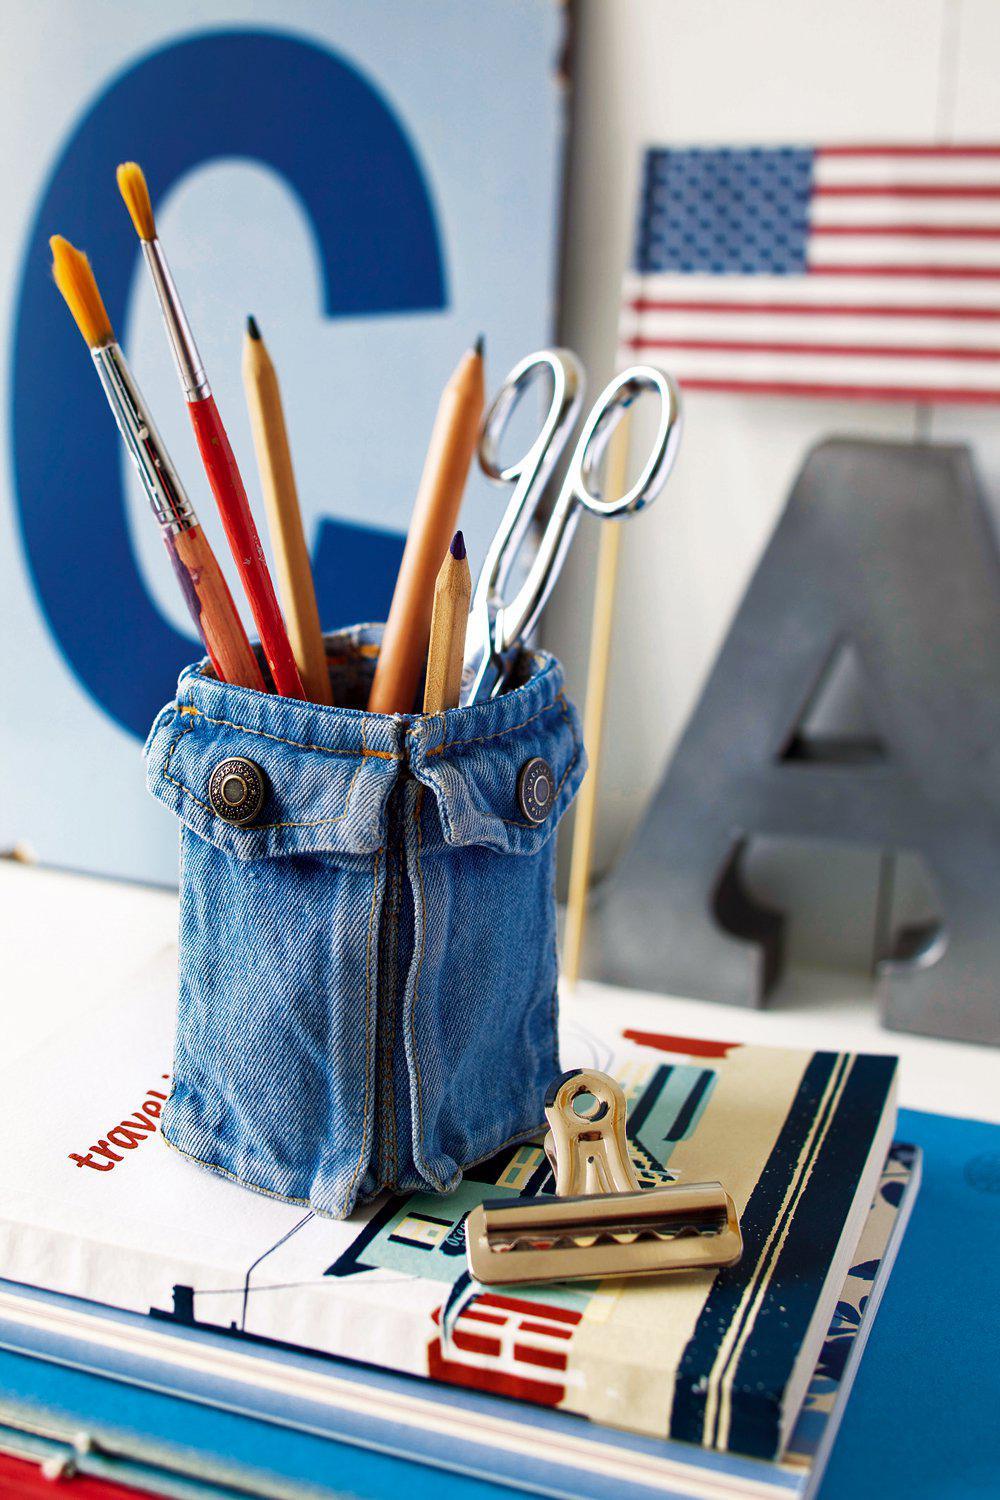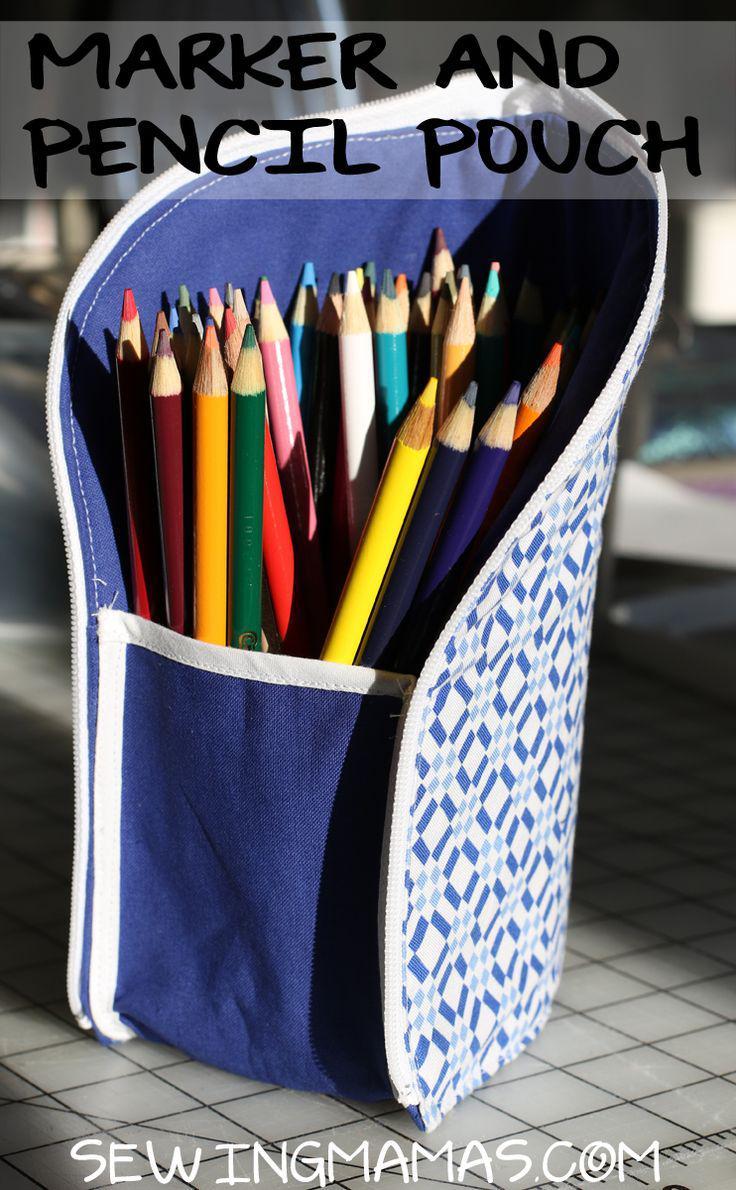The first image is the image on the left, the second image is the image on the right. Examine the images to the left and right. Is the description "Pencils sit horizontally in a container in the image on the left." accurate? Answer yes or no. No. 